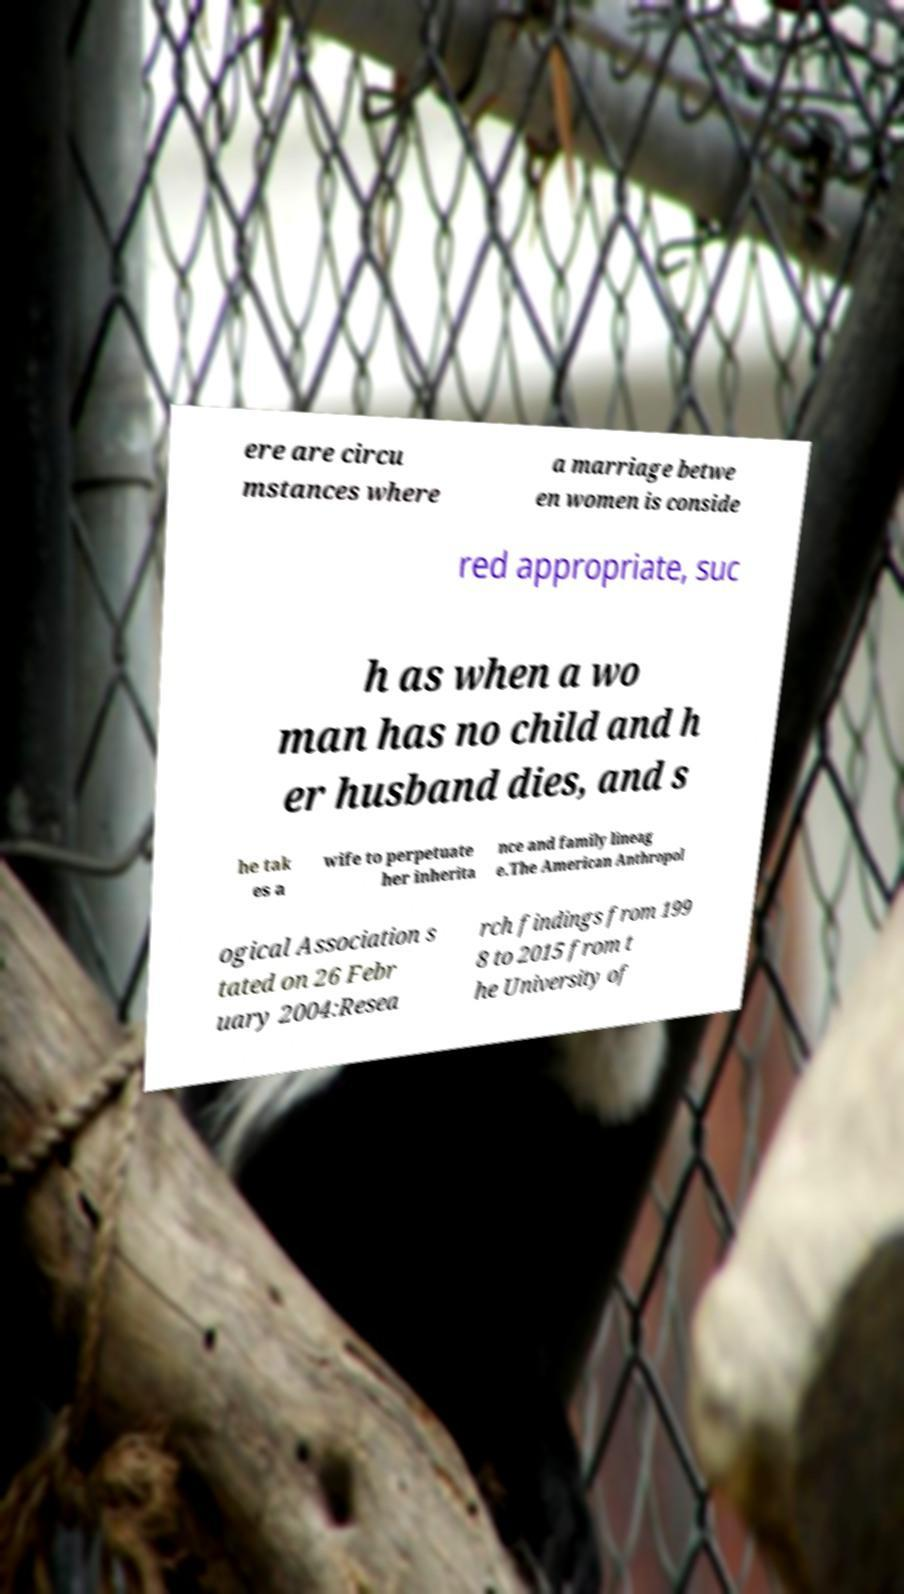What messages or text are displayed in this image? I need them in a readable, typed format. ere are circu mstances where a marriage betwe en women is conside red appropriate, suc h as when a wo man has no child and h er husband dies, and s he tak es a wife to perpetuate her inherita nce and family lineag e.The American Anthropol ogical Association s tated on 26 Febr uary 2004:Resea rch findings from 199 8 to 2015 from t he University of 